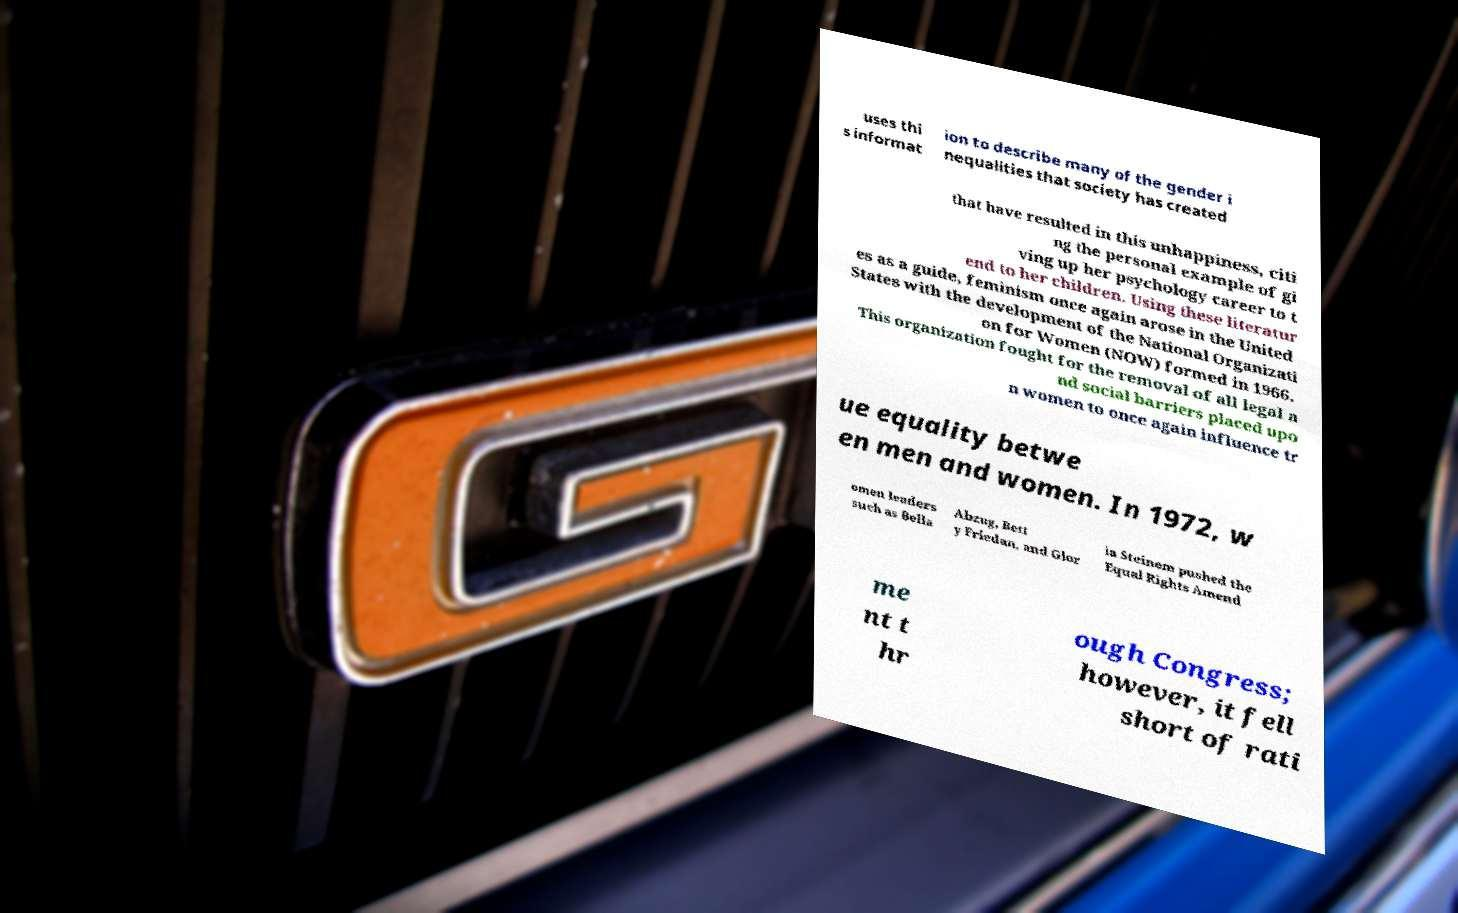What messages or text are displayed in this image? I need them in a readable, typed format. uses thi s informat ion to describe many of the gender i nequalities that society has created that have resulted in this unhappiness, citi ng the personal example of gi ving up her psychology career to t end to her children. Using these literatur es as a guide, feminism once again arose in the United States with the development of the National Organizati on for Women (NOW) formed in 1966. This organization fought for the removal of all legal a nd social barriers placed upo n women to once again influence tr ue equality betwe en men and women. In 1972, w omen leaders such as Bella Abzug, Bett y Friedan, and Glor ia Steinem pushed the Equal Rights Amend me nt t hr ough Congress; however, it fell short of rati 